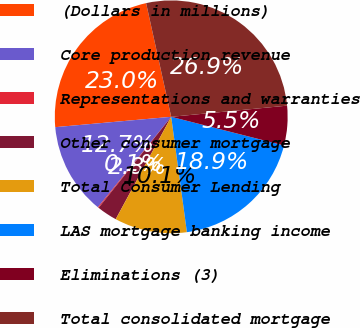Convert chart. <chart><loc_0><loc_0><loc_500><loc_500><pie_chart><fcel>(Dollars in millions)<fcel>Core production revenue<fcel>Representations and warranties<fcel>Other consumer mortgage<fcel>Total Consumer Lending<fcel>LAS mortgage banking income<fcel>Eliminations (3)<fcel>Total consolidated mortgage<nl><fcel>22.96%<fcel>12.74%<fcel>0.13%<fcel>2.81%<fcel>10.06%<fcel>18.89%<fcel>5.49%<fcel>26.93%<nl></chart> 